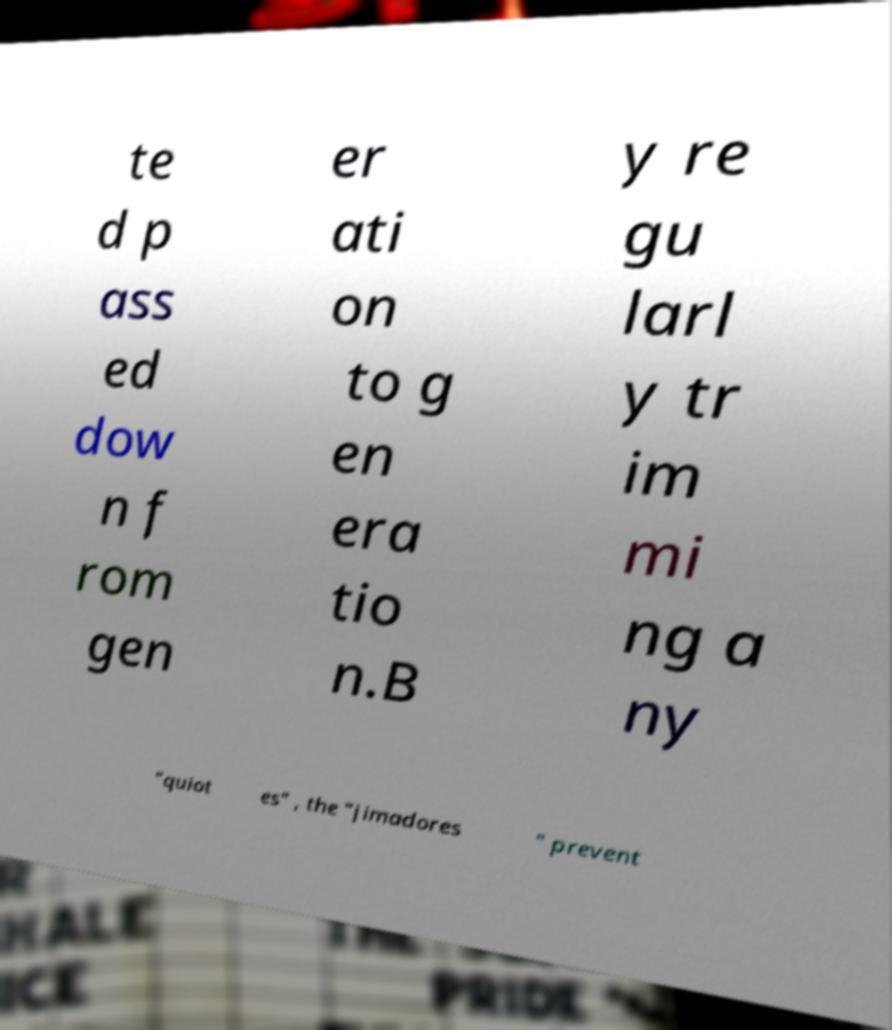Could you extract and type out the text from this image? te d p ass ed dow n f rom gen er ati on to g en era tio n.B y re gu larl y tr im mi ng a ny "quiot es" , the "jimadores " prevent 